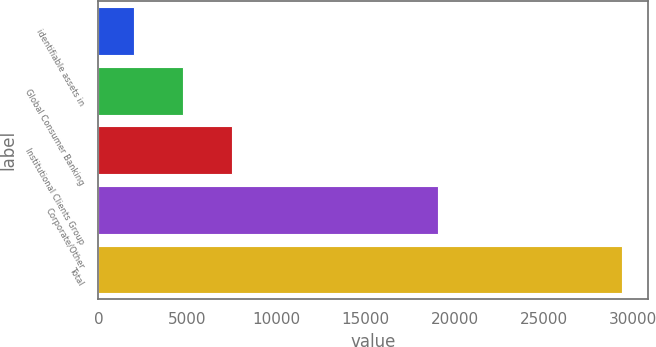Convert chart to OTSL. <chart><loc_0><loc_0><loc_500><loc_500><bar_chart><fcel>identifiable assets in<fcel>Global Consumer Banking<fcel>Institutional Clients Group<fcel>Corporate/Other<fcel>Total<nl><fcel>2017<fcel>4754.1<fcel>7491.2<fcel>19064<fcel>29388<nl></chart> 